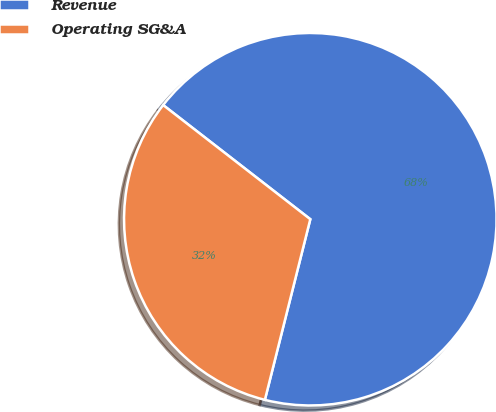Convert chart. <chart><loc_0><loc_0><loc_500><loc_500><pie_chart><fcel>Revenue<fcel>Operating SG&A<nl><fcel>68.42%<fcel>31.58%<nl></chart> 